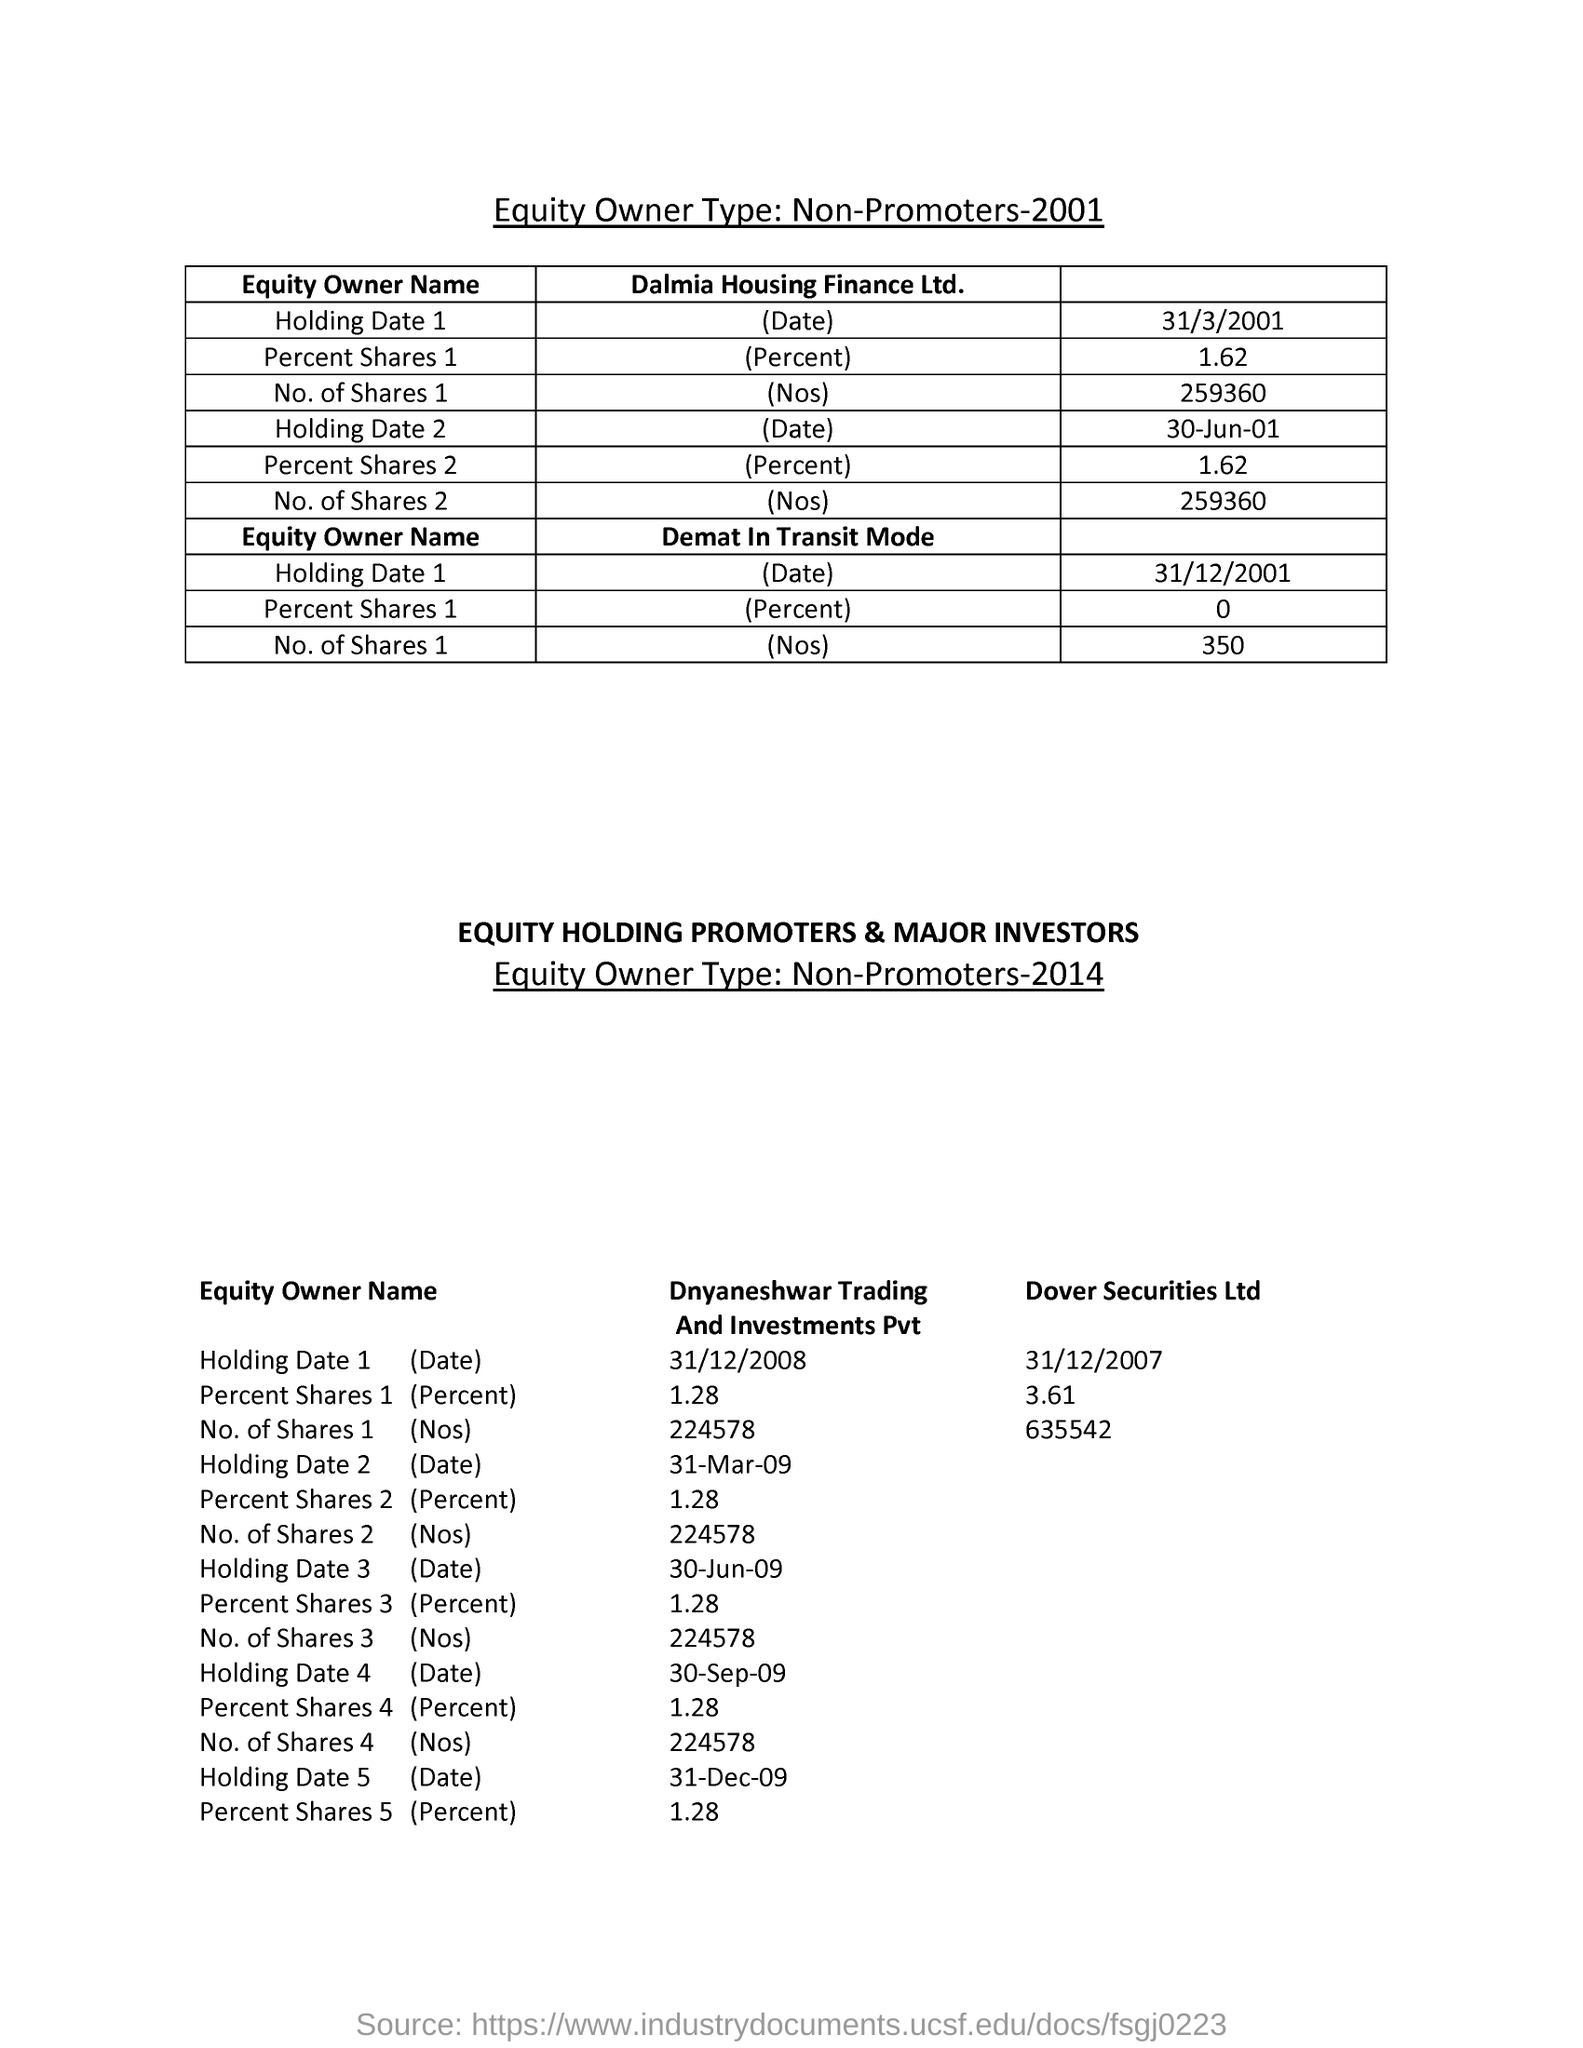What was the "Holding Date 1" which was shown in the second row?
Make the answer very short. 31/3/2001. 